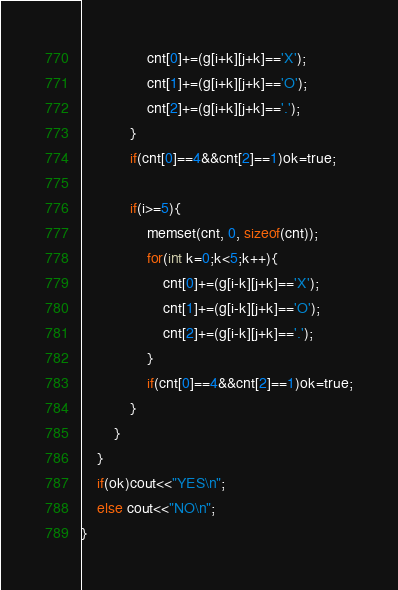<code> <loc_0><loc_0><loc_500><loc_500><_C++_>				cnt[0]+=(g[i+k][j+k]=='X');
				cnt[1]+=(g[i+k][j+k]=='O');
				cnt[2]+=(g[i+k][j+k]=='.');
			}
			if(cnt[0]==4&&cnt[2]==1)ok=true;

			if(i>=5){
				memset(cnt, 0, sizeof(cnt));
				for(int k=0;k<5;k++){
					cnt[0]+=(g[i-k][j+k]=='X');
					cnt[1]+=(g[i-k][j+k]=='O');
					cnt[2]+=(g[i-k][j+k]=='.');
				}
				if(cnt[0]==4&&cnt[2]==1)ok=true;
			}
		}
	}
	if(ok)cout<<"YES\n";
	else cout<<"NO\n";
}

</code> 